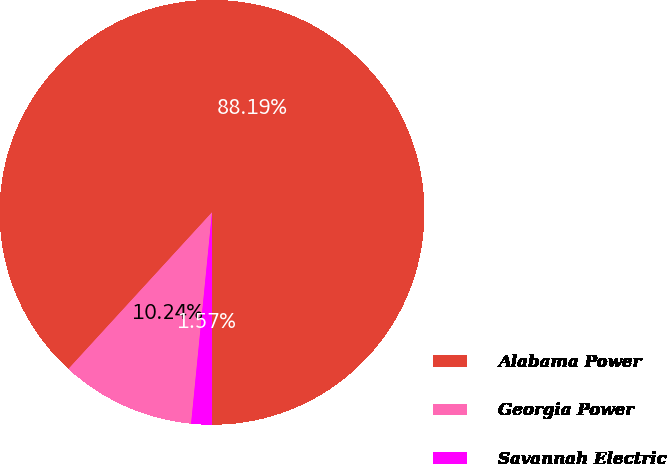<chart> <loc_0><loc_0><loc_500><loc_500><pie_chart><fcel>Alabama Power<fcel>Georgia Power<fcel>Savannah Electric<nl><fcel>88.19%<fcel>10.24%<fcel>1.57%<nl></chart> 